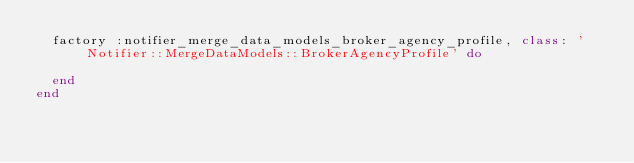<code> <loc_0><loc_0><loc_500><loc_500><_Ruby_>  factory :notifier_merge_data_models_broker_agency_profile, class: 'Notifier::MergeDataModels::BrokerAgencyProfile' do
    
  end
end
</code> 